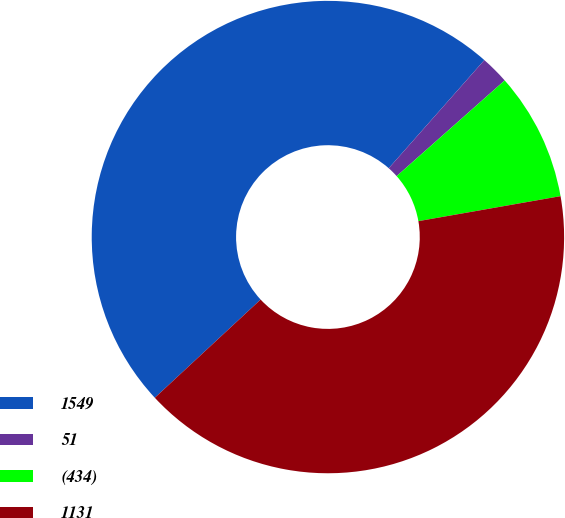<chart> <loc_0><loc_0><loc_500><loc_500><pie_chart><fcel>1549<fcel>51<fcel>(434)<fcel>1131<nl><fcel>48.43%<fcel>1.94%<fcel>8.77%<fcel>40.86%<nl></chart> 